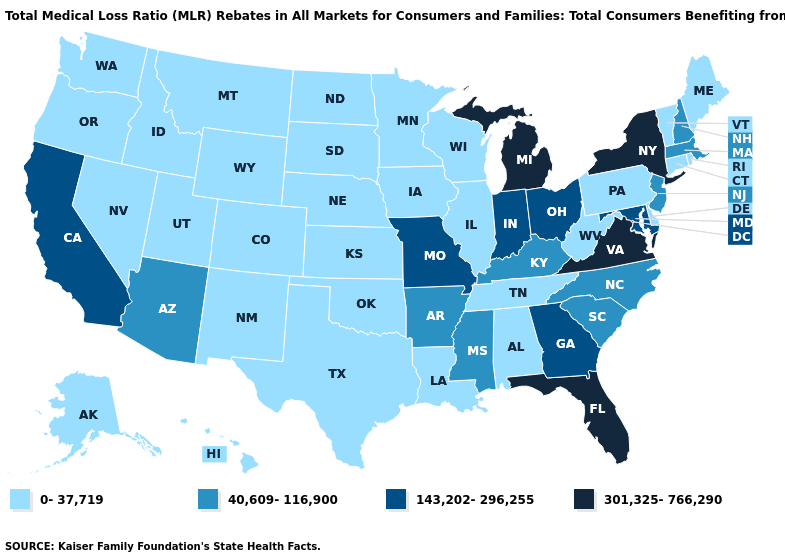What is the value of Ohio?
Short answer required. 143,202-296,255. Does South Carolina have the highest value in the USA?
Answer briefly. No. Name the states that have a value in the range 301,325-766,290?
Concise answer only. Florida, Michigan, New York, Virginia. What is the value of Oklahoma?
Short answer required. 0-37,719. What is the lowest value in the USA?
Concise answer only. 0-37,719. Does Florida have the lowest value in the USA?
Keep it brief. No. Does Georgia have a lower value than Michigan?
Keep it brief. Yes. Does Ohio have the lowest value in the MidWest?
Short answer required. No. Name the states that have a value in the range 301,325-766,290?
Concise answer only. Florida, Michigan, New York, Virginia. Which states hav the highest value in the MidWest?
Give a very brief answer. Michigan. Among the states that border Rhode Island , which have the lowest value?
Quick response, please. Connecticut. Name the states that have a value in the range 0-37,719?
Keep it brief. Alabama, Alaska, Colorado, Connecticut, Delaware, Hawaii, Idaho, Illinois, Iowa, Kansas, Louisiana, Maine, Minnesota, Montana, Nebraska, Nevada, New Mexico, North Dakota, Oklahoma, Oregon, Pennsylvania, Rhode Island, South Dakota, Tennessee, Texas, Utah, Vermont, Washington, West Virginia, Wisconsin, Wyoming. What is the value of Arkansas?
Write a very short answer. 40,609-116,900. Name the states that have a value in the range 143,202-296,255?
Give a very brief answer. California, Georgia, Indiana, Maryland, Missouri, Ohio. 